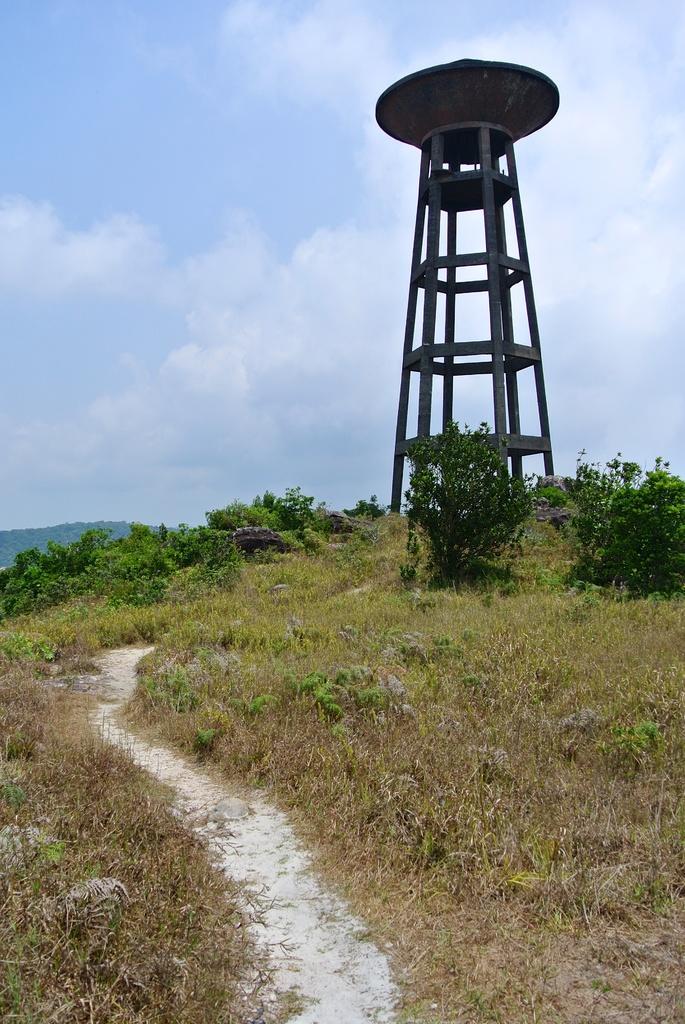In one or two sentences, can you explain what this image depicts? In the image there is a lot of grass and some plants , in the background there is a tower. 